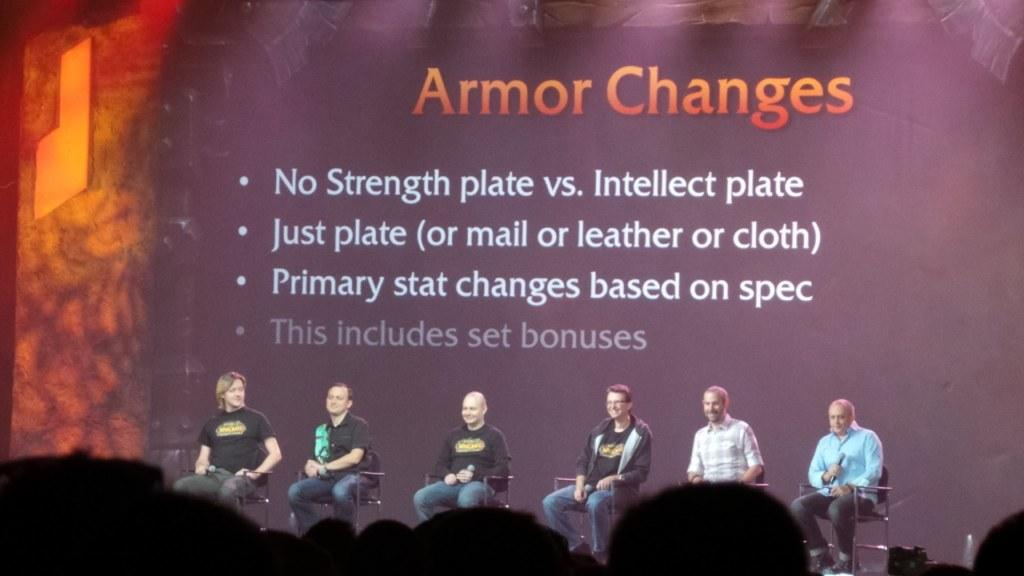What is happening on the stage in the image? There is a group of people sitting on chairs on a stage. Who is present in front of the stage? There is an audience in front of the stage. What can be seen behind the people on the stage? There is a banner with text behind the people on the stage. How many letters are visible on the banner in the image? There is no specific information about the number of letters on the banner in the image. What type of bead is being used as a decoration on the chairs on the stage? There is no mention of beads or any decorations on the chairs in the image. 